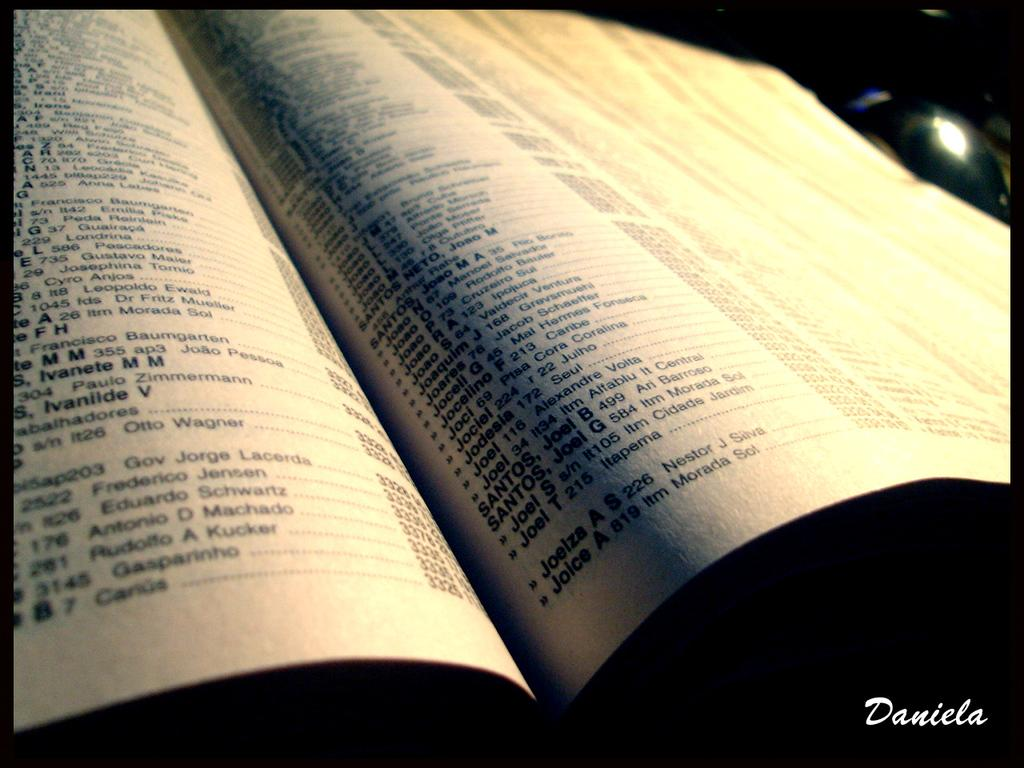<image>
Describe the image concisely. a book with the name 'antonio d machado' in it 